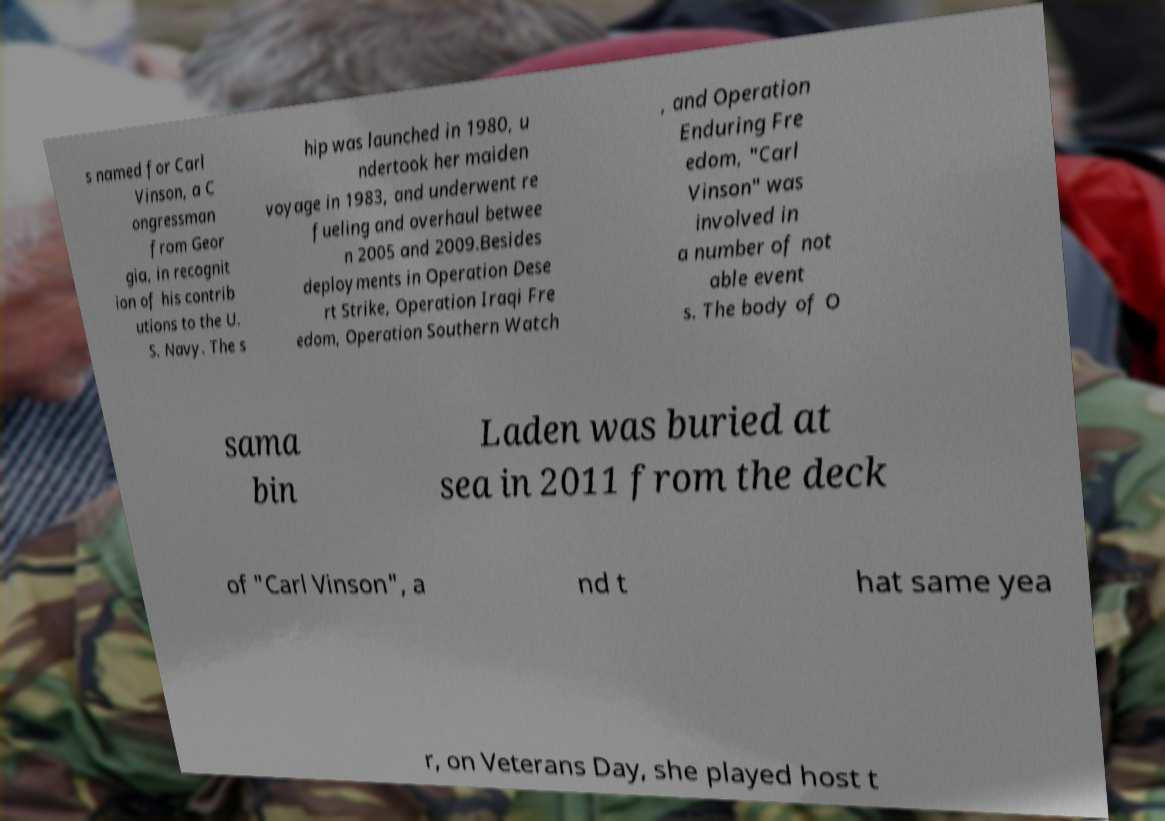There's text embedded in this image that I need extracted. Can you transcribe it verbatim? s named for Carl Vinson, a C ongressman from Geor gia, in recognit ion of his contrib utions to the U. S. Navy. The s hip was launched in 1980, u ndertook her maiden voyage in 1983, and underwent re fueling and overhaul betwee n 2005 and 2009.Besides deployments in Operation Dese rt Strike, Operation Iraqi Fre edom, Operation Southern Watch , and Operation Enduring Fre edom, "Carl Vinson" was involved in a number of not able event s. The body of O sama bin Laden was buried at sea in 2011 from the deck of "Carl Vinson", a nd t hat same yea r, on Veterans Day, she played host t 